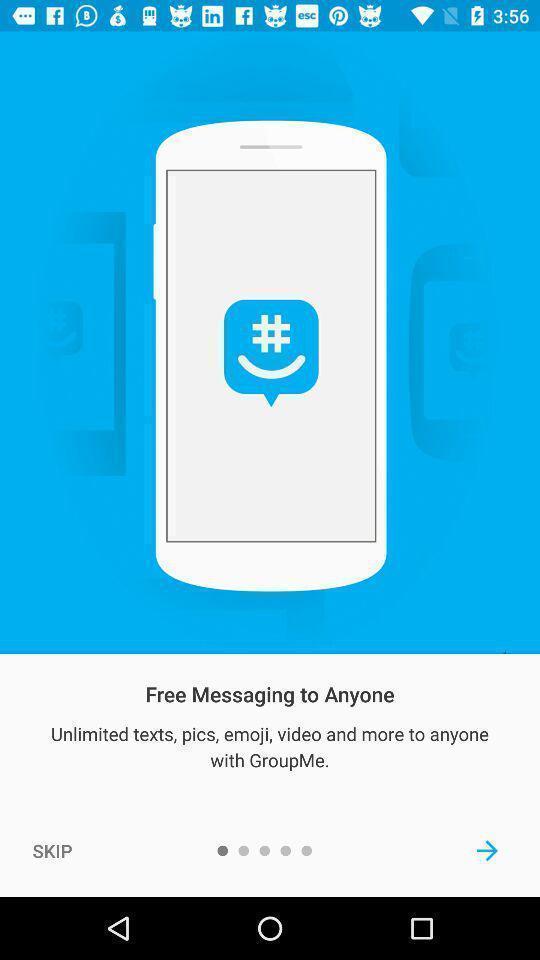Describe this image in words. Welcome page of a messenger app. 